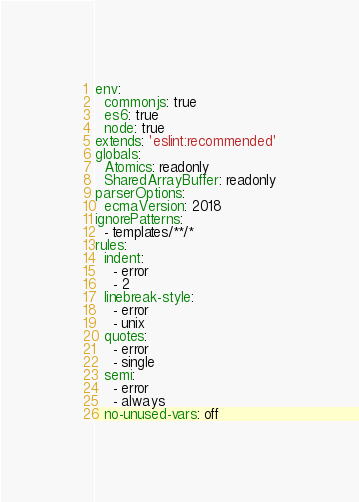<code> <loc_0><loc_0><loc_500><loc_500><_YAML_>env:
  commonjs: true
  es6: true
  node: true
extends: 'eslint:recommended'
globals:
  Atomics: readonly
  SharedArrayBuffer: readonly
parserOptions:
  ecmaVersion: 2018
ignorePatterns:
  - templates/**/*
rules:
  indent:
    - error
    - 2
  linebreak-style:
    - error
    - unix
  quotes:
    - error
    - single
  semi:
    - error
    - always
  no-unused-vars: off
</code> 